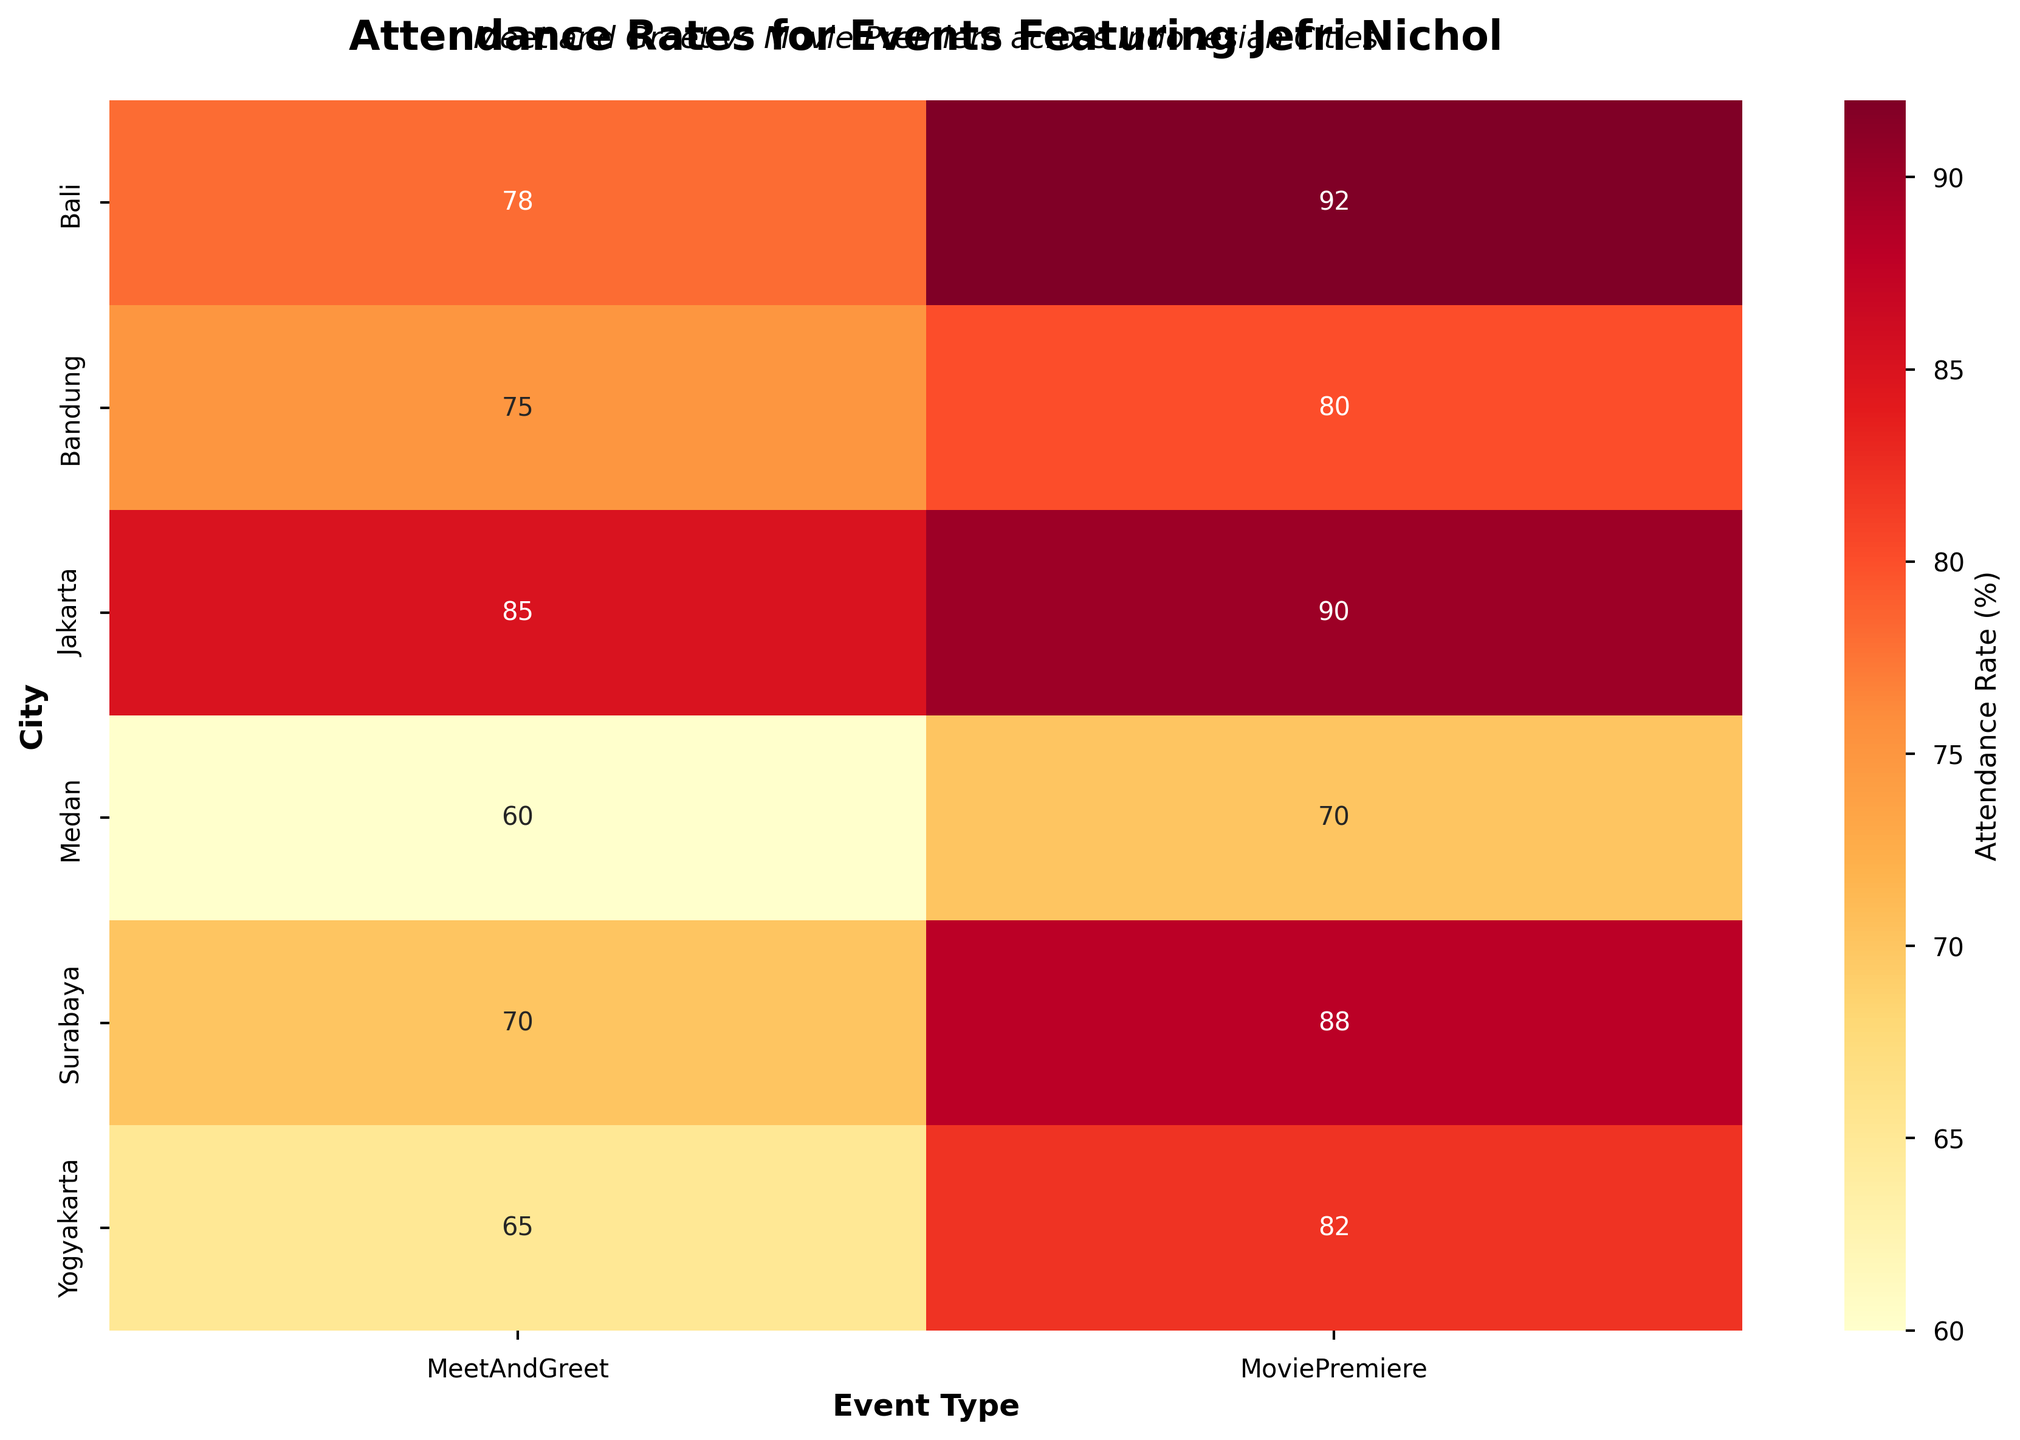Which event in Bali had the highest attendance rate? Look at the row corresponding to Bali and compare the attendance rate for the two events. The Movie Premiere has a higher attendance rate than the Meet and Greet.
Answer: Movie Premiere What is the difference in attendance rates between the Meet and Greet in Jakarta and the Meet and Greet in Medan? Identify the attendance rates for the Meet and Greet in Jakarta (85) and Medan (60) and find their difference: 85 - 60 = 25.
Answer: 25 Which city had the lowest attendance rate for the Meet and Greet? Compare the attendance rates for the Meet and Greet across all cities. The lowest rate is in Medan with 60%.
Answer: Medan Is the attendance rate for the Movie Premiere generally higher or lower than for the Meet and Greet across all cities? Compare the attendance rates for the Movie Premiere and Meet and Greet for each city. In most cases, the Movie Premiere has a higher attendance rate.
Answer: Higher What is the average attendance rate for the Movie Premiere events across all cities? Sum the attendance rates for the Movie Premiere events across all cities (90+80+88+82+70+92=502). Divide by the number of cities (6): 502/6 = 83.67. Round to two decimal places.
Answer: 83.67 Which city had the closest attendance rates between the Meet and Greet and the Movie Premiere? Calculate the absolute differences between the Meet and Greet and Movie Premiere attendance rates in all cities. Bandung has the smallest difference, with Meet and Greet at 75, and Movie Premiere at 80, giving a difference of 5%.
Answer: Bandung What is the title of the figure? Look at the top of the heatmap; the title is usually displayed there.
Answer: "Attendance Rates for Events Featuring Jefri Nichol" In which city is the attendance rate for the Movie Premiere the second highest? Find the highest rate first, which is 92 in Bali. The second highest rate is 90 in Jakarta.
Answer: Jakarta Which city showed the least difference in attendance rates between the two events? Calculate the difference in attendance rates for each city and compare them. Bandung has the smallest difference with 75 for Meet and Greet and 80 for Movie Premiere, resulting in a difference of 5%.
Answer: Bandung Which event generally had a lower attendance rate in Yogyakarta? Compare the two attendance rates for events in Yogyakarta: Meet and Greet (65) and Movie Premiere (82). The Meet and Greet has a lower rate.
Answer: Meet and Greet 